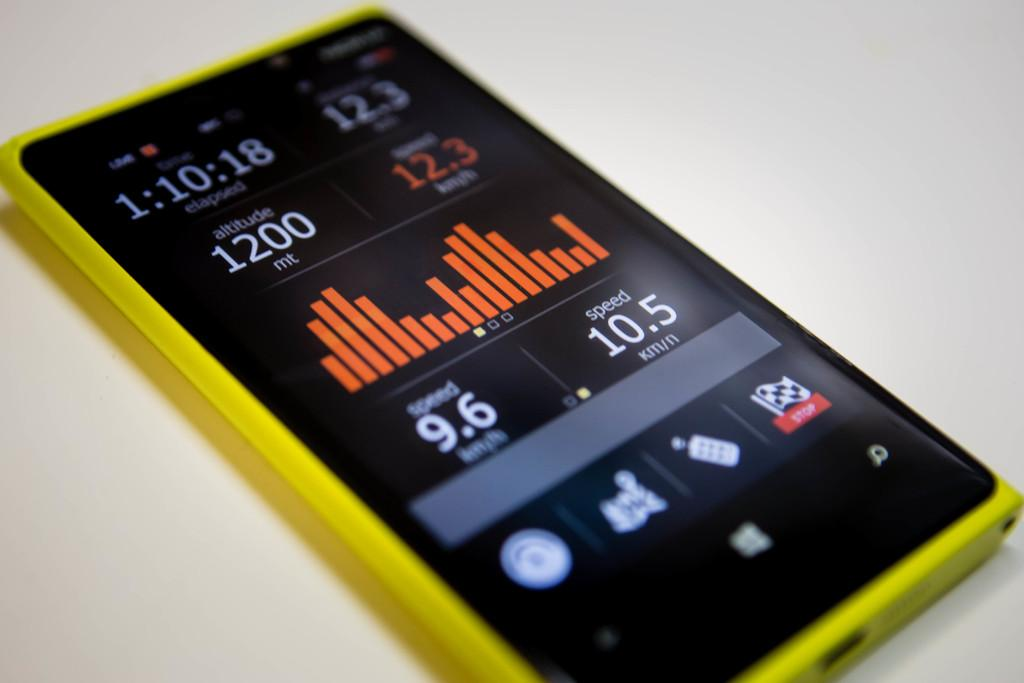<image>
Summarize the visual content of the image. Black and yellow phone that has the number 10.5 as the speed. 